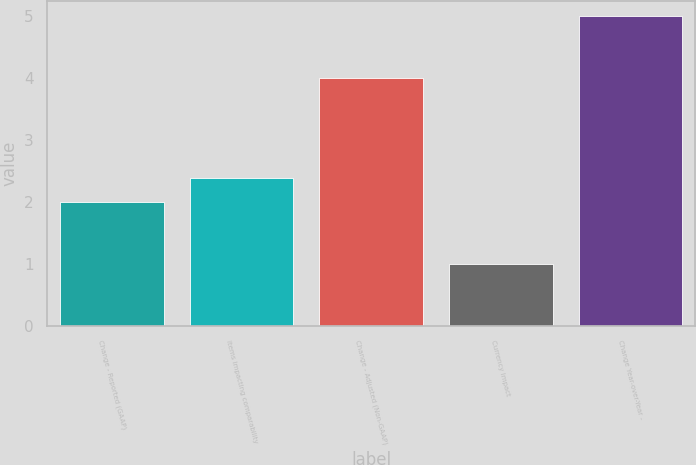Convert chart. <chart><loc_0><loc_0><loc_500><loc_500><bar_chart><fcel>Change - Reported (GAAP)<fcel>Items impacting comparability<fcel>Change - Adjusted (Non-GAAP)<fcel>Currency Impact<fcel>Change Year-over-Year -<nl><fcel>2<fcel>2.4<fcel>4<fcel>1<fcel>5<nl></chart> 